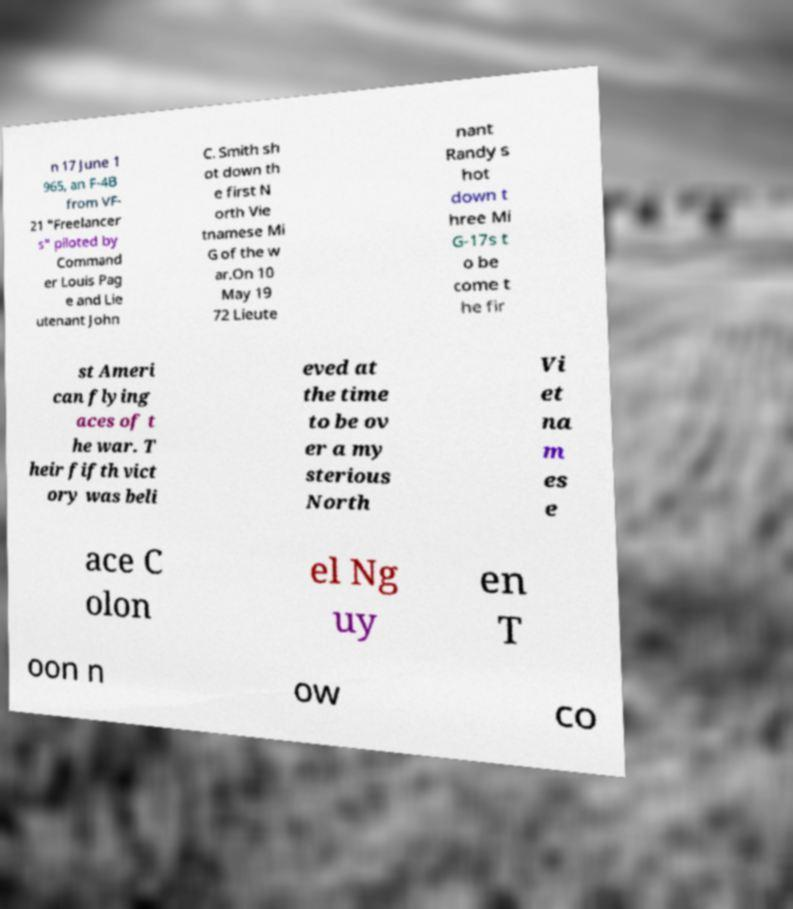Please read and relay the text visible in this image. What does it say? n 17 June 1 965, an F-4B from VF- 21 "Freelancer s" piloted by Command er Louis Pag e and Lie utenant John C. Smith sh ot down th e first N orth Vie tnamese Mi G of the w ar.On 10 May 19 72 Lieute nant Randy s hot down t hree Mi G-17s t o be come t he fir st Ameri can flying aces of t he war. T heir fifth vict ory was beli eved at the time to be ov er a my sterious North Vi et na m es e ace C olon el Ng uy en T oon n ow co 